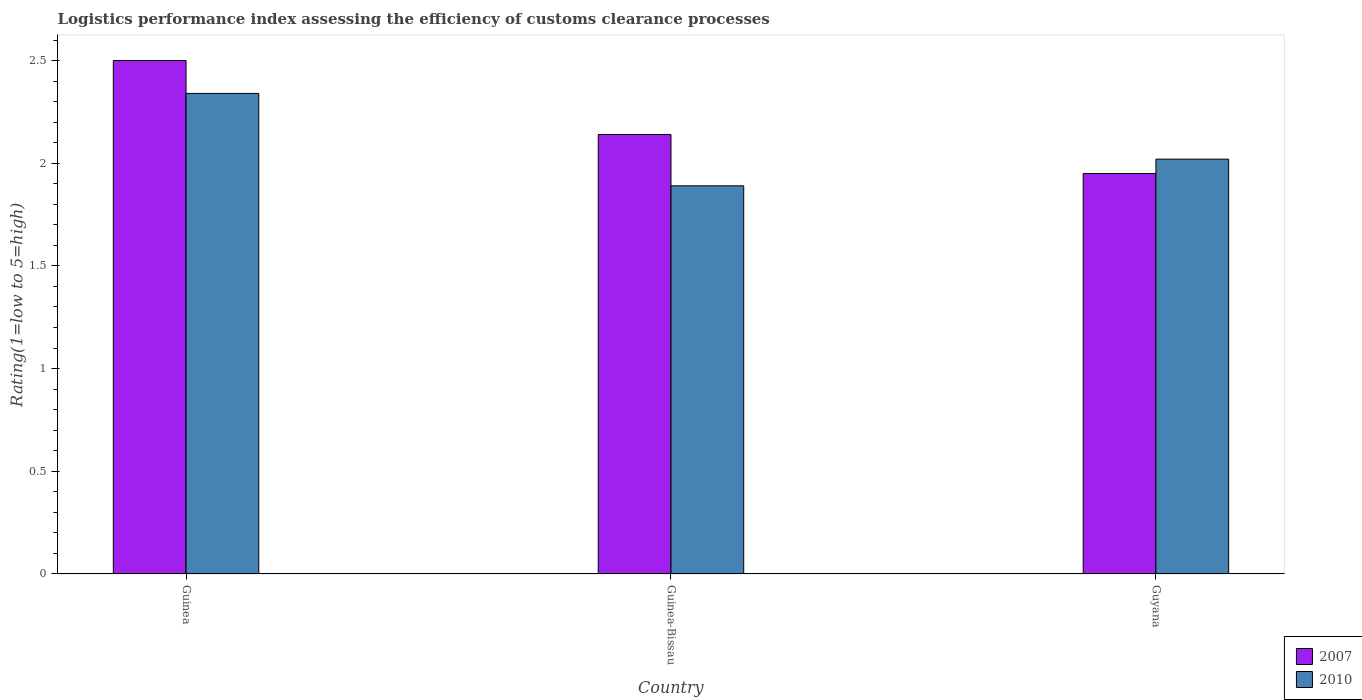How many different coloured bars are there?
Give a very brief answer. 2. How many groups of bars are there?
Your answer should be very brief. 3. How many bars are there on the 3rd tick from the right?
Ensure brevity in your answer.  2. What is the label of the 2nd group of bars from the left?
Provide a short and direct response. Guinea-Bissau. In how many cases, is the number of bars for a given country not equal to the number of legend labels?
Give a very brief answer. 0. What is the Logistic performance index in 2010 in Guyana?
Your answer should be very brief. 2.02. Across all countries, what is the maximum Logistic performance index in 2007?
Your answer should be very brief. 2.5. Across all countries, what is the minimum Logistic performance index in 2007?
Offer a very short reply. 1.95. In which country was the Logistic performance index in 2007 maximum?
Offer a very short reply. Guinea. In which country was the Logistic performance index in 2007 minimum?
Your answer should be compact. Guyana. What is the total Logistic performance index in 2010 in the graph?
Make the answer very short. 6.25. What is the difference between the Logistic performance index in 2007 in Guinea and that in Guinea-Bissau?
Your response must be concise. 0.36. What is the difference between the Logistic performance index in 2007 in Guinea-Bissau and the Logistic performance index in 2010 in Guyana?
Keep it short and to the point. 0.12. What is the average Logistic performance index in 2007 per country?
Give a very brief answer. 2.2. What is the difference between the Logistic performance index of/in 2007 and Logistic performance index of/in 2010 in Guyana?
Your answer should be compact. -0.07. What is the ratio of the Logistic performance index in 2010 in Guinea-Bissau to that in Guyana?
Provide a short and direct response. 0.94. Is the Logistic performance index in 2010 in Guinea-Bissau less than that in Guyana?
Offer a terse response. Yes. What is the difference between the highest and the second highest Logistic performance index in 2007?
Offer a terse response. -0.55. What is the difference between the highest and the lowest Logistic performance index in 2010?
Your answer should be compact. 0.45. What does the 2nd bar from the left in Guinea-Bissau represents?
Provide a succinct answer. 2010. Are all the bars in the graph horizontal?
Provide a succinct answer. No. Does the graph contain any zero values?
Ensure brevity in your answer.  No. Does the graph contain grids?
Make the answer very short. No. What is the title of the graph?
Your answer should be very brief. Logistics performance index assessing the efficiency of customs clearance processes. Does "1975" appear as one of the legend labels in the graph?
Keep it short and to the point. No. What is the label or title of the X-axis?
Keep it short and to the point. Country. What is the label or title of the Y-axis?
Your answer should be very brief. Rating(1=low to 5=high). What is the Rating(1=low to 5=high) of 2007 in Guinea?
Ensure brevity in your answer.  2.5. What is the Rating(1=low to 5=high) in 2010 in Guinea?
Offer a terse response. 2.34. What is the Rating(1=low to 5=high) in 2007 in Guinea-Bissau?
Give a very brief answer. 2.14. What is the Rating(1=low to 5=high) of 2010 in Guinea-Bissau?
Ensure brevity in your answer.  1.89. What is the Rating(1=low to 5=high) of 2007 in Guyana?
Offer a very short reply. 1.95. What is the Rating(1=low to 5=high) in 2010 in Guyana?
Make the answer very short. 2.02. Across all countries, what is the maximum Rating(1=low to 5=high) in 2010?
Offer a terse response. 2.34. Across all countries, what is the minimum Rating(1=low to 5=high) of 2007?
Your answer should be very brief. 1.95. Across all countries, what is the minimum Rating(1=low to 5=high) in 2010?
Offer a terse response. 1.89. What is the total Rating(1=low to 5=high) in 2007 in the graph?
Make the answer very short. 6.59. What is the total Rating(1=low to 5=high) of 2010 in the graph?
Offer a terse response. 6.25. What is the difference between the Rating(1=low to 5=high) in 2007 in Guinea and that in Guinea-Bissau?
Offer a terse response. 0.36. What is the difference between the Rating(1=low to 5=high) in 2010 in Guinea and that in Guinea-Bissau?
Your answer should be compact. 0.45. What is the difference between the Rating(1=low to 5=high) of 2007 in Guinea and that in Guyana?
Make the answer very short. 0.55. What is the difference between the Rating(1=low to 5=high) of 2010 in Guinea and that in Guyana?
Ensure brevity in your answer.  0.32. What is the difference between the Rating(1=low to 5=high) of 2007 in Guinea-Bissau and that in Guyana?
Offer a terse response. 0.19. What is the difference between the Rating(1=low to 5=high) in 2010 in Guinea-Bissau and that in Guyana?
Offer a terse response. -0.13. What is the difference between the Rating(1=low to 5=high) of 2007 in Guinea and the Rating(1=low to 5=high) of 2010 in Guinea-Bissau?
Your answer should be compact. 0.61. What is the difference between the Rating(1=low to 5=high) of 2007 in Guinea and the Rating(1=low to 5=high) of 2010 in Guyana?
Keep it short and to the point. 0.48. What is the difference between the Rating(1=low to 5=high) in 2007 in Guinea-Bissau and the Rating(1=low to 5=high) in 2010 in Guyana?
Your answer should be very brief. 0.12. What is the average Rating(1=low to 5=high) of 2007 per country?
Offer a terse response. 2.2. What is the average Rating(1=low to 5=high) of 2010 per country?
Keep it short and to the point. 2.08. What is the difference between the Rating(1=low to 5=high) in 2007 and Rating(1=low to 5=high) in 2010 in Guinea?
Give a very brief answer. 0.16. What is the difference between the Rating(1=low to 5=high) in 2007 and Rating(1=low to 5=high) in 2010 in Guinea-Bissau?
Your answer should be compact. 0.25. What is the difference between the Rating(1=low to 5=high) of 2007 and Rating(1=low to 5=high) of 2010 in Guyana?
Keep it short and to the point. -0.07. What is the ratio of the Rating(1=low to 5=high) in 2007 in Guinea to that in Guinea-Bissau?
Your answer should be compact. 1.17. What is the ratio of the Rating(1=low to 5=high) of 2010 in Guinea to that in Guinea-Bissau?
Provide a short and direct response. 1.24. What is the ratio of the Rating(1=low to 5=high) in 2007 in Guinea to that in Guyana?
Offer a very short reply. 1.28. What is the ratio of the Rating(1=low to 5=high) of 2010 in Guinea to that in Guyana?
Provide a short and direct response. 1.16. What is the ratio of the Rating(1=low to 5=high) in 2007 in Guinea-Bissau to that in Guyana?
Offer a very short reply. 1.1. What is the ratio of the Rating(1=low to 5=high) of 2010 in Guinea-Bissau to that in Guyana?
Offer a terse response. 0.94. What is the difference between the highest and the second highest Rating(1=low to 5=high) in 2007?
Give a very brief answer. 0.36. What is the difference between the highest and the second highest Rating(1=low to 5=high) of 2010?
Ensure brevity in your answer.  0.32. What is the difference between the highest and the lowest Rating(1=low to 5=high) of 2007?
Provide a succinct answer. 0.55. What is the difference between the highest and the lowest Rating(1=low to 5=high) of 2010?
Your answer should be very brief. 0.45. 